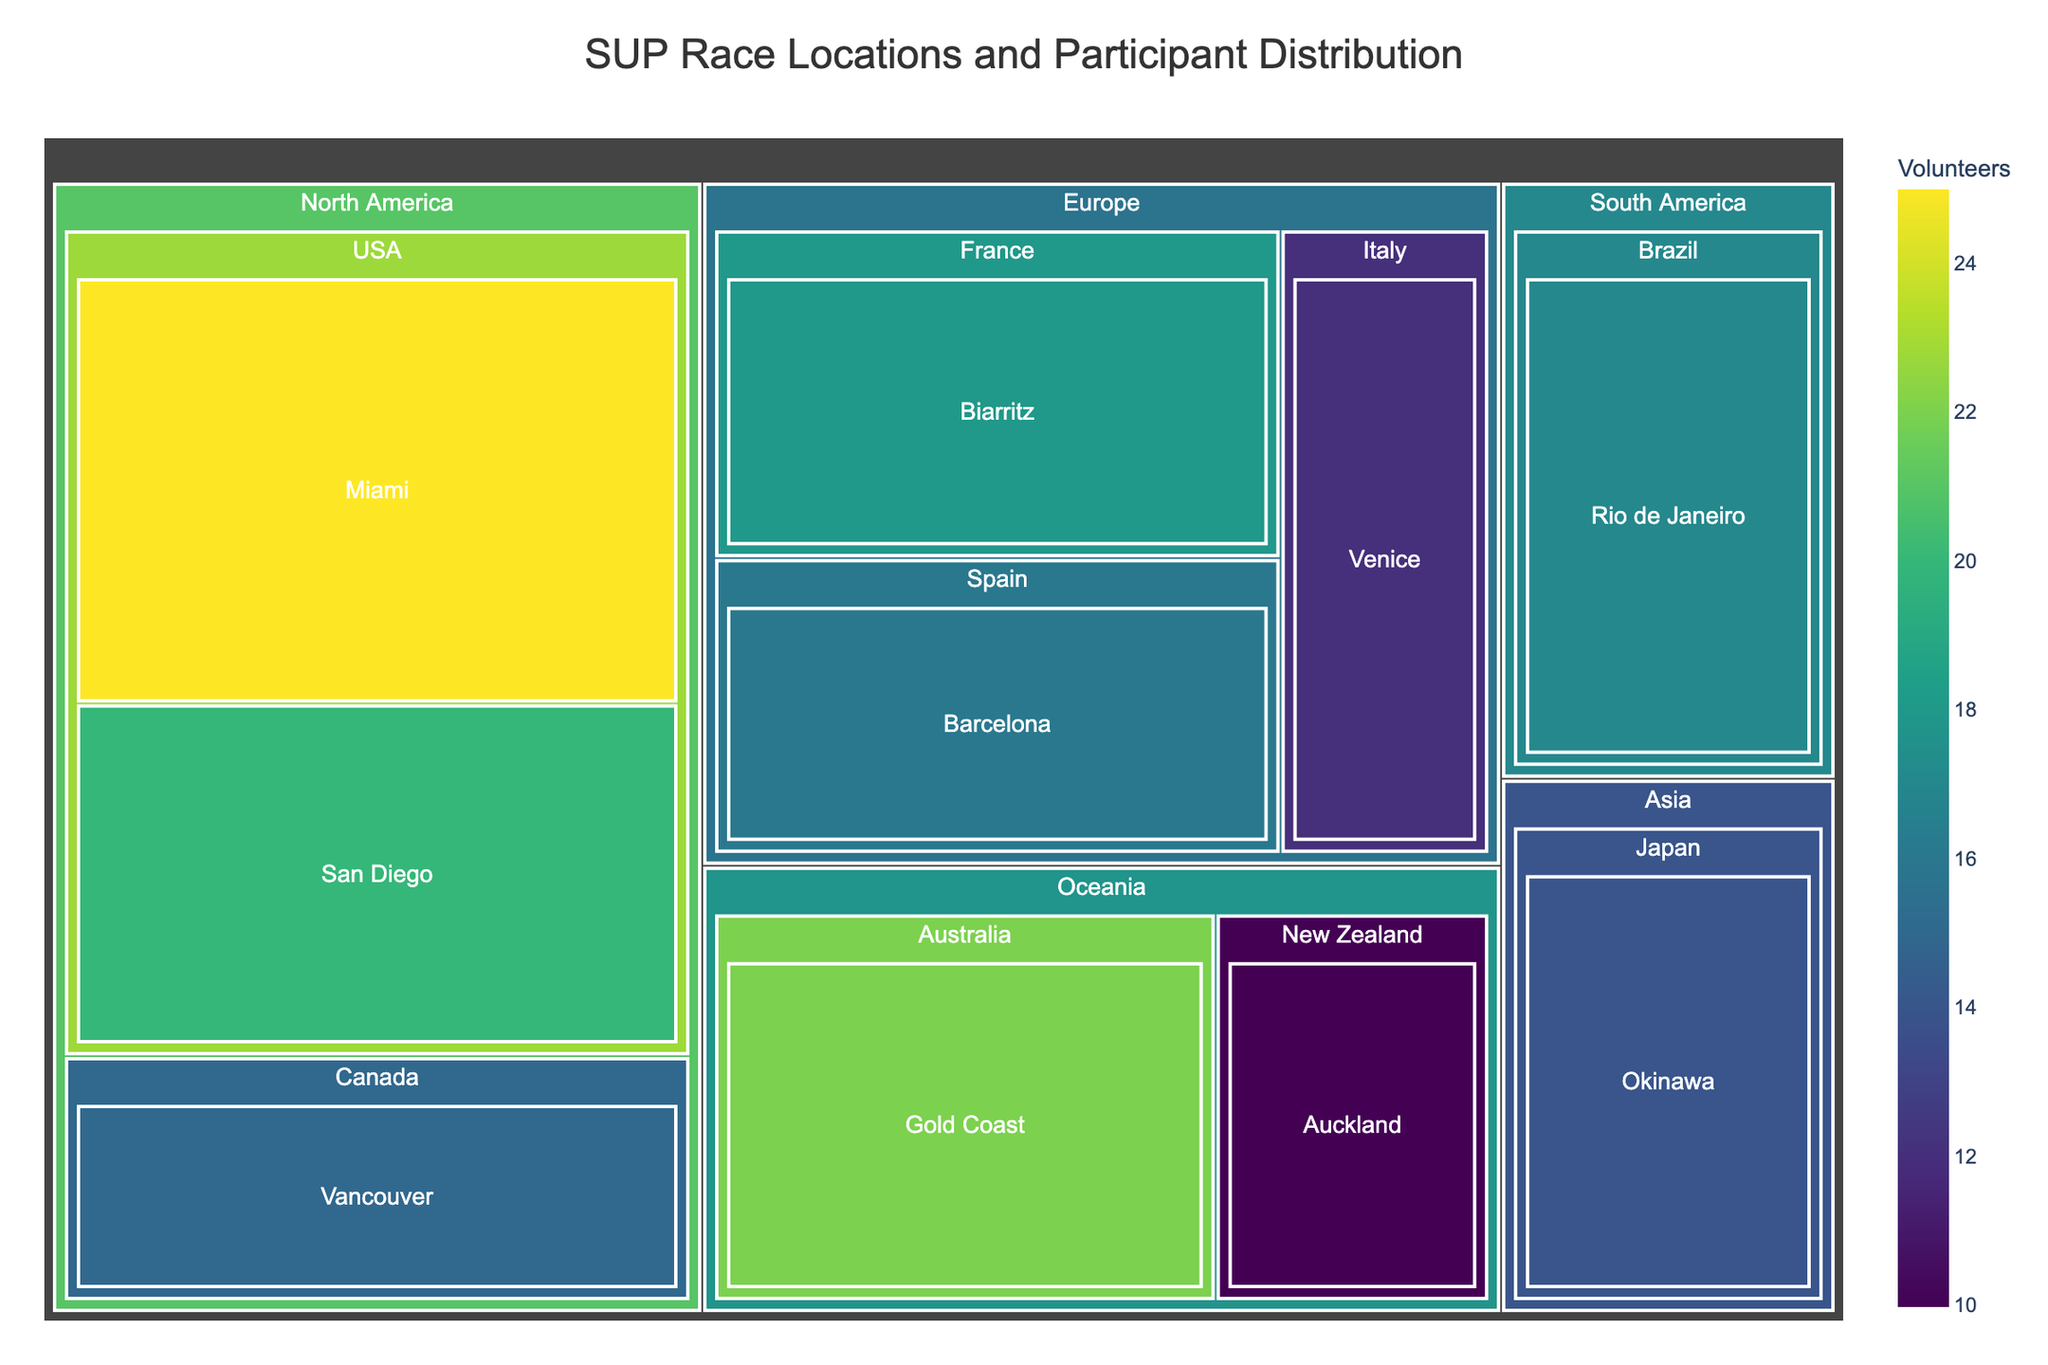What is the title of the Treemap? The title is often displayed prominently at the top of the chart and serves to inform the viewer about the context of the data visualized.
Answer: SUP Race Locations and Participant Distribution Which city has the highest number of participants? Scan the treemap for the section with the largest area since the size correlates with the number of participants. The largest section belongs to Miami.
Answer: Miami What is the total number of participants in North America? North America consists of Miami, San Diego, and Vancouver. Sum their participants: 150 + 120 + 80.
Answer: 350 Which region has the most volunteers? Compare all regions by the combined volunteer count from all cities within each region. North America's total volunteers (25+20+15) equal 60, while Europe has 46, Oceania 32, Asia 14, and South America 17.
Answer: North America How many cities in total are represented in the treemap? Count all the distinct city names, which are listed in the figure.
Answer: 10 Which city in Europe has the fewest participants? Locate European cities and identify the one with the smallest section, which indicates the fewest participants. Venice, with 70 participants, is the smallest.
Answer: Venice Between Sydney and Auckland, which city has more volunteers? Compare the volunteer count of the two cities in Oceania. Sydney has 22 volunteers, and Auckland has 10.
Answer: Sydney What is the ratio of participants to volunteers in Rio de Janeiro? Divide the number of participants by the number of volunteers for Rio de Janeiro (95 participants, 17 volunteers). 95 / 17 = 5.59.
Answer: 5.59 Which region has fewer participants: Asia or South America? Compare the total participants from the cities within Asia (Okinawa: 85) and South America (Rio de Janeiro: 95).
Answer: Asia What is the average number of volunteers per city in Europe? Sum the volunteers from the European cities (18+16+12 = 46) and divide by the number of cities (3). 46 / 3 ≈ 15.33.
Answer: 15.33 